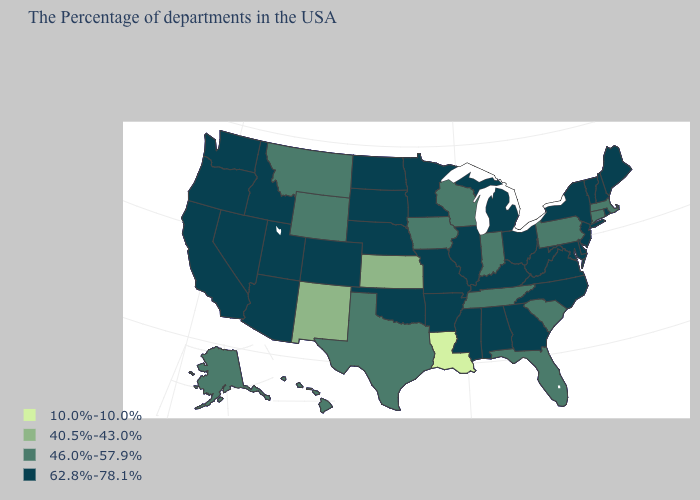Among the states that border Connecticut , which have the lowest value?
Keep it brief. Massachusetts. What is the highest value in the MidWest ?
Be succinct. 62.8%-78.1%. What is the value of Kentucky?
Quick response, please. 62.8%-78.1%. Is the legend a continuous bar?
Answer briefly. No. What is the value of North Carolina?
Write a very short answer. 62.8%-78.1%. Among the states that border North Dakota , does Minnesota have the highest value?
Short answer required. Yes. What is the highest value in states that border North Carolina?
Concise answer only. 62.8%-78.1%. What is the lowest value in the USA?
Keep it brief. 10.0%-10.0%. What is the highest value in the USA?
Give a very brief answer. 62.8%-78.1%. Does Ohio have the lowest value in the MidWest?
Write a very short answer. No. Does Virginia have a higher value than Texas?
Give a very brief answer. Yes. Does Pennsylvania have a lower value than Arizona?
Give a very brief answer. Yes. Which states have the lowest value in the West?
Concise answer only. New Mexico. Name the states that have a value in the range 10.0%-10.0%?
Keep it brief. Louisiana. Name the states that have a value in the range 40.5%-43.0%?
Quick response, please. Kansas, New Mexico. 